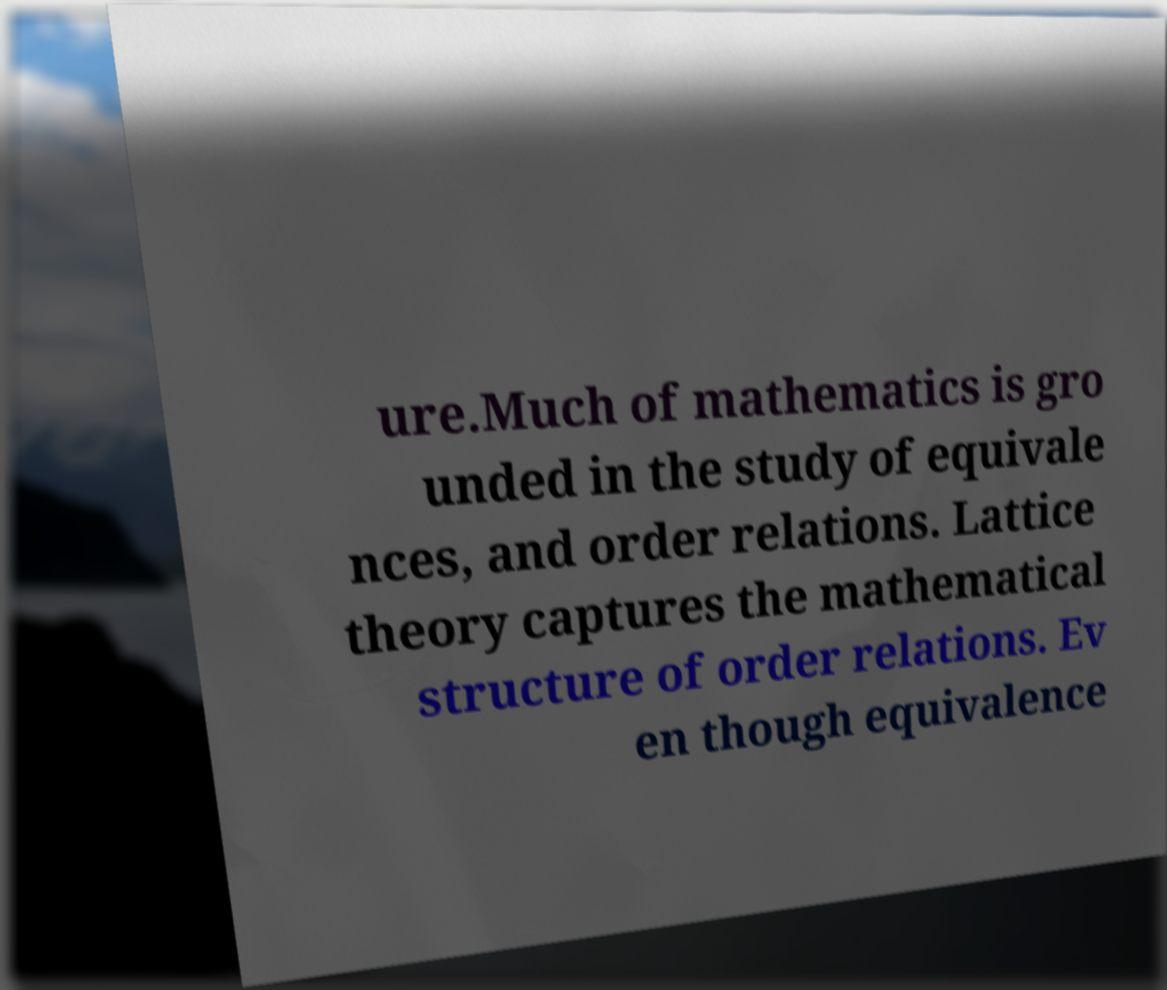Could you assist in decoding the text presented in this image and type it out clearly? ure.Much of mathematics is gro unded in the study of equivale nces, and order relations. Lattice theory captures the mathematical structure of order relations. Ev en though equivalence 